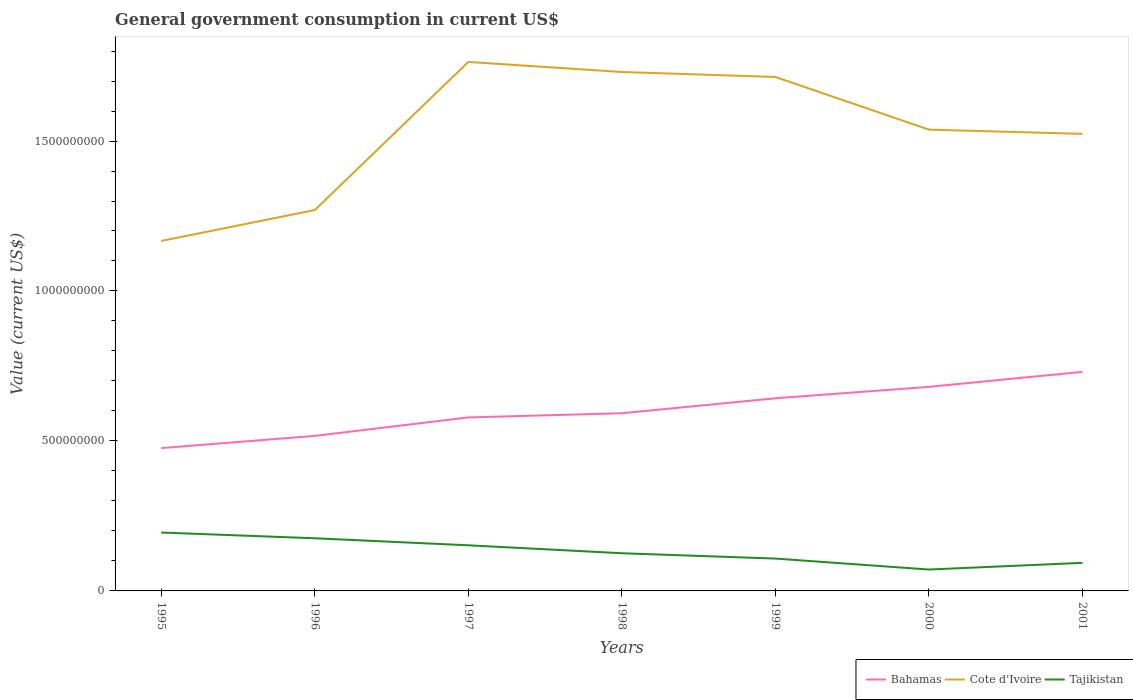Does the line corresponding to Bahamas intersect with the line corresponding to Cote d'Ivoire?
Your response must be concise. No. Across all years, what is the maximum government conusmption in Tajikistan?
Make the answer very short. 7.13e+07. In which year was the government conusmption in Cote d'Ivoire maximum?
Your answer should be very brief. 1995. What is the total government conusmption in Tajikistan in the graph?
Provide a short and direct response. 6.77e+07. What is the difference between the highest and the second highest government conusmption in Tajikistan?
Make the answer very short. 1.23e+08. What is the difference between the highest and the lowest government conusmption in Cote d'Ivoire?
Your answer should be compact. 4. Does the graph contain grids?
Your answer should be compact. No. Where does the legend appear in the graph?
Your response must be concise. Bottom right. How many legend labels are there?
Give a very brief answer. 3. What is the title of the graph?
Keep it short and to the point. General government consumption in current US$. What is the label or title of the Y-axis?
Your response must be concise. Value (current US$). What is the Value (current US$) in Bahamas in 1995?
Your response must be concise. 4.76e+08. What is the Value (current US$) in Cote d'Ivoire in 1995?
Your answer should be compact. 1.17e+09. What is the Value (current US$) of Tajikistan in 1995?
Provide a succinct answer. 1.95e+08. What is the Value (current US$) of Bahamas in 1996?
Make the answer very short. 5.17e+08. What is the Value (current US$) in Cote d'Ivoire in 1996?
Offer a terse response. 1.27e+09. What is the Value (current US$) in Tajikistan in 1996?
Provide a succinct answer. 1.76e+08. What is the Value (current US$) in Bahamas in 1997?
Make the answer very short. 5.78e+08. What is the Value (current US$) in Cote d'Ivoire in 1997?
Your response must be concise. 1.76e+09. What is the Value (current US$) of Tajikistan in 1997?
Offer a terse response. 1.52e+08. What is the Value (current US$) in Bahamas in 1998?
Ensure brevity in your answer.  5.92e+08. What is the Value (current US$) in Cote d'Ivoire in 1998?
Your answer should be very brief. 1.73e+09. What is the Value (current US$) in Tajikistan in 1998?
Give a very brief answer. 1.26e+08. What is the Value (current US$) in Bahamas in 1999?
Your answer should be very brief. 6.42e+08. What is the Value (current US$) in Cote d'Ivoire in 1999?
Keep it short and to the point. 1.71e+09. What is the Value (current US$) in Tajikistan in 1999?
Provide a short and direct response. 1.08e+08. What is the Value (current US$) in Bahamas in 2000?
Your answer should be compact. 6.80e+08. What is the Value (current US$) in Cote d'Ivoire in 2000?
Provide a succinct answer. 1.54e+09. What is the Value (current US$) of Tajikistan in 2000?
Offer a very short reply. 7.13e+07. What is the Value (current US$) in Bahamas in 2001?
Your answer should be very brief. 7.30e+08. What is the Value (current US$) of Cote d'Ivoire in 2001?
Ensure brevity in your answer.  1.52e+09. What is the Value (current US$) of Tajikistan in 2001?
Your response must be concise. 9.36e+07. Across all years, what is the maximum Value (current US$) in Bahamas?
Your answer should be very brief. 7.30e+08. Across all years, what is the maximum Value (current US$) in Cote d'Ivoire?
Your response must be concise. 1.76e+09. Across all years, what is the maximum Value (current US$) of Tajikistan?
Provide a short and direct response. 1.95e+08. Across all years, what is the minimum Value (current US$) in Bahamas?
Make the answer very short. 4.76e+08. Across all years, what is the minimum Value (current US$) in Cote d'Ivoire?
Make the answer very short. 1.17e+09. Across all years, what is the minimum Value (current US$) in Tajikistan?
Your answer should be very brief. 7.13e+07. What is the total Value (current US$) of Bahamas in the graph?
Keep it short and to the point. 4.22e+09. What is the total Value (current US$) in Cote d'Ivoire in the graph?
Ensure brevity in your answer.  1.07e+1. What is the total Value (current US$) in Tajikistan in the graph?
Your answer should be compact. 9.21e+08. What is the difference between the Value (current US$) in Bahamas in 1995 and that in 1996?
Your answer should be compact. -4.07e+07. What is the difference between the Value (current US$) in Cote d'Ivoire in 1995 and that in 1996?
Provide a short and direct response. -1.03e+08. What is the difference between the Value (current US$) of Tajikistan in 1995 and that in 1996?
Provide a short and direct response. 1.91e+07. What is the difference between the Value (current US$) of Bahamas in 1995 and that in 1997?
Provide a succinct answer. -1.02e+08. What is the difference between the Value (current US$) in Cote d'Ivoire in 1995 and that in 1997?
Keep it short and to the point. -5.97e+08. What is the difference between the Value (current US$) in Tajikistan in 1995 and that in 1997?
Ensure brevity in your answer.  4.26e+07. What is the difference between the Value (current US$) of Bahamas in 1995 and that in 1998?
Your response must be concise. -1.16e+08. What is the difference between the Value (current US$) of Cote d'Ivoire in 1995 and that in 1998?
Provide a short and direct response. -5.63e+08. What is the difference between the Value (current US$) of Tajikistan in 1995 and that in 1998?
Your answer should be very brief. 6.90e+07. What is the difference between the Value (current US$) in Bahamas in 1995 and that in 1999?
Provide a succinct answer. -1.66e+08. What is the difference between the Value (current US$) of Cote d'Ivoire in 1995 and that in 1999?
Ensure brevity in your answer.  -5.47e+08. What is the difference between the Value (current US$) of Tajikistan in 1995 and that in 1999?
Offer a terse response. 8.68e+07. What is the difference between the Value (current US$) in Bahamas in 1995 and that in 2000?
Your answer should be compact. -2.04e+08. What is the difference between the Value (current US$) of Cote d'Ivoire in 1995 and that in 2000?
Give a very brief answer. -3.71e+08. What is the difference between the Value (current US$) of Tajikistan in 1995 and that in 2000?
Make the answer very short. 1.23e+08. What is the difference between the Value (current US$) in Bahamas in 1995 and that in 2001?
Ensure brevity in your answer.  -2.54e+08. What is the difference between the Value (current US$) in Cote d'Ivoire in 1995 and that in 2001?
Make the answer very short. -3.57e+08. What is the difference between the Value (current US$) of Tajikistan in 1995 and that in 2001?
Provide a short and direct response. 1.01e+08. What is the difference between the Value (current US$) of Bahamas in 1996 and that in 1997?
Your answer should be compact. -6.16e+07. What is the difference between the Value (current US$) of Cote d'Ivoire in 1996 and that in 1997?
Your answer should be very brief. -4.94e+08. What is the difference between the Value (current US$) of Tajikistan in 1996 and that in 1997?
Provide a short and direct response. 2.35e+07. What is the difference between the Value (current US$) of Bahamas in 1996 and that in 1998?
Your response must be concise. -7.55e+07. What is the difference between the Value (current US$) in Cote d'Ivoire in 1996 and that in 1998?
Your answer should be very brief. -4.60e+08. What is the difference between the Value (current US$) of Tajikistan in 1996 and that in 1998?
Provide a succinct answer. 4.99e+07. What is the difference between the Value (current US$) of Bahamas in 1996 and that in 1999?
Ensure brevity in your answer.  -1.25e+08. What is the difference between the Value (current US$) of Cote d'Ivoire in 1996 and that in 1999?
Your answer should be very brief. -4.44e+08. What is the difference between the Value (current US$) in Tajikistan in 1996 and that in 1999?
Your answer should be compact. 6.77e+07. What is the difference between the Value (current US$) in Bahamas in 1996 and that in 2000?
Give a very brief answer. -1.64e+08. What is the difference between the Value (current US$) of Cote d'Ivoire in 1996 and that in 2000?
Ensure brevity in your answer.  -2.68e+08. What is the difference between the Value (current US$) in Tajikistan in 1996 and that in 2000?
Provide a succinct answer. 1.04e+08. What is the difference between the Value (current US$) of Bahamas in 1996 and that in 2001?
Provide a succinct answer. -2.14e+08. What is the difference between the Value (current US$) in Cote d'Ivoire in 1996 and that in 2001?
Provide a short and direct response. -2.54e+08. What is the difference between the Value (current US$) in Tajikistan in 1996 and that in 2001?
Provide a short and direct response. 8.20e+07. What is the difference between the Value (current US$) in Bahamas in 1997 and that in 1998?
Offer a terse response. -1.39e+07. What is the difference between the Value (current US$) of Cote d'Ivoire in 1997 and that in 1998?
Make the answer very short. 3.34e+07. What is the difference between the Value (current US$) in Tajikistan in 1997 and that in 1998?
Your response must be concise. 2.64e+07. What is the difference between the Value (current US$) in Bahamas in 1997 and that in 1999?
Make the answer very short. -6.38e+07. What is the difference between the Value (current US$) of Cote d'Ivoire in 1997 and that in 1999?
Offer a terse response. 5.01e+07. What is the difference between the Value (current US$) of Tajikistan in 1997 and that in 1999?
Provide a succinct answer. 4.43e+07. What is the difference between the Value (current US$) of Bahamas in 1997 and that in 2000?
Your response must be concise. -1.02e+08. What is the difference between the Value (current US$) of Cote d'Ivoire in 1997 and that in 2000?
Your response must be concise. 2.26e+08. What is the difference between the Value (current US$) in Tajikistan in 1997 and that in 2000?
Ensure brevity in your answer.  8.08e+07. What is the difference between the Value (current US$) of Bahamas in 1997 and that in 2001?
Ensure brevity in your answer.  -1.52e+08. What is the difference between the Value (current US$) in Cote d'Ivoire in 1997 and that in 2001?
Keep it short and to the point. 2.40e+08. What is the difference between the Value (current US$) in Tajikistan in 1997 and that in 2001?
Offer a very short reply. 5.85e+07. What is the difference between the Value (current US$) in Bahamas in 1998 and that in 1999?
Your answer should be very brief. -4.99e+07. What is the difference between the Value (current US$) in Cote d'Ivoire in 1998 and that in 1999?
Make the answer very short. 1.67e+07. What is the difference between the Value (current US$) in Tajikistan in 1998 and that in 1999?
Your answer should be very brief. 1.78e+07. What is the difference between the Value (current US$) in Bahamas in 1998 and that in 2000?
Offer a terse response. -8.80e+07. What is the difference between the Value (current US$) in Cote d'Ivoire in 1998 and that in 2000?
Ensure brevity in your answer.  1.92e+08. What is the difference between the Value (current US$) in Tajikistan in 1998 and that in 2000?
Your answer should be very brief. 5.43e+07. What is the difference between the Value (current US$) in Bahamas in 1998 and that in 2001?
Your response must be concise. -1.38e+08. What is the difference between the Value (current US$) of Cote d'Ivoire in 1998 and that in 2001?
Provide a short and direct response. 2.06e+08. What is the difference between the Value (current US$) in Tajikistan in 1998 and that in 2001?
Your answer should be very brief. 3.21e+07. What is the difference between the Value (current US$) in Bahamas in 1999 and that in 2000?
Ensure brevity in your answer.  -3.81e+07. What is the difference between the Value (current US$) of Cote d'Ivoire in 1999 and that in 2000?
Give a very brief answer. 1.75e+08. What is the difference between the Value (current US$) in Tajikistan in 1999 and that in 2000?
Your answer should be compact. 3.65e+07. What is the difference between the Value (current US$) in Bahamas in 1999 and that in 2001?
Ensure brevity in your answer.  -8.81e+07. What is the difference between the Value (current US$) of Cote d'Ivoire in 1999 and that in 2001?
Provide a succinct answer. 1.90e+08. What is the difference between the Value (current US$) in Tajikistan in 1999 and that in 2001?
Your answer should be very brief. 1.43e+07. What is the difference between the Value (current US$) of Bahamas in 2000 and that in 2001?
Provide a short and direct response. -5.00e+07. What is the difference between the Value (current US$) of Cote d'Ivoire in 2000 and that in 2001?
Offer a very short reply. 1.41e+07. What is the difference between the Value (current US$) of Tajikistan in 2000 and that in 2001?
Provide a succinct answer. -2.22e+07. What is the difference between the Value (current US$) in Bahamas in 1995 and the Value (current US$) in Cote d'Ivoire in 1996?
Your answer should be compact. -7.94e+08. What is the difference between the Value (current US$) in Bahamas in 1995 and the Value (current US$) in Tajikistan in 1996?
Offer a terse response. 3.01e+08. What is the difference between the Value (current US$) of Cote d'Ivoire in 1995 and the Value (current US$) of Tajikistan in 1996?
Make the answer very short. 9.91e+08. What is the difference between the Value (current US$) in Bahamas in 1995 and the Value (current US$) in Cote d'Ivoire in 1997?
Your answer should be very brief. -1.29e+09. What is the difference between the Value (current US$) in Bahamas in 1995 and the Value (current US$) in Tajikistan in 1997?
Provide a succinct answer. 3.24e+08. What is the difference between the Value (current US$) of Cote d'Ivoire in 1995 and the Value (current US$) of Tajikistan in 1997?
Offer a terse response. 1.01e+09. What is the difference between the Value (current US$) of Bahamas in 1995 and the Value (current US$) of Cote d'Ivoire in 1998?
Offer a very short reply. -1.25e+09. What is the difference between the Value (current US$) in Bahamas in 1995 and the Value (current US$) in Tajikistan in 1998?
Offer a very short reply. 3.51e+08. What is the difference between the Value (current US$) in Cote d'Ivoire in 1995 and the Value (current US$) in Tajikistan in 1998?
Make the answer very short. 1.04e+09. What is the difference between the Value (current US$) of Bahamas in 1995 and the Value (current US$) of Cote d'Ivoire in 1999?
Offer a terse response. -1.24e+09. What is the difference between the Value (current US$) in Bahamas in 1995 and the Value (current US$) in Tajikistan in 1999?
Offer a very short reply. 3.68e+08. What is the difference between the Value (current US$) of Cote d'Ivoire in 1995 and the Value (current US$) of Tajikistan in 1999?
Give a very brief answer. 1.06e+09. What is the difference between the Value (current US$) of Bahamas in 1995 and the Value (current US$) of Cote d'Ivoire in 2000?
Keep it short and to the point. -1.06e+09. What is the difference between the Value (current US$) in Bahamas in 1995 and the Value (current US$) in Tajikistan in 2000?
Provide a succinct answer. 4.05e+08. What is the difference between the Value (current US$) in Cote d'Ivoire in 1995 and the Value (current US$) in Tajikistan in 2000?
Provide a succinct answer. 1.10e+09. What is the difference between the Value (current US$) of Bahamas in 1995 and the Value (current US$) of Cote d'Ivoire in 2001?
Ensure brevity in your answer.  -1.05e+09. What is the difference between the Value (current US$) of Bahamas in 1995 and the Value (current US$) of Tajikistan in 2001?
Offer a very short reply. 3.83e+08. What is the difference between the Value (current US$) of Cote d'Ivoire in 1995 and the Value (current US$) of Tajikistan in 2001?
Your answer should be compact. 1.07e+09. What is the difference between the Value (current US$) of Bahamas in 1996 and the Value (current US$) of Cote d'Ivoire in 1997?
Your answer should be very brief. -1.25e+09. What is the difference between the Value (current US$) in Bahamas in 1996 and the Value (current US$) in Tajikistan in 1997?
Provide a short and direct response. 3.65e+08. What is the difference between the Value (current US$) in Cote d'Ivoire in 1996 and the Value (current US$) in Tajikistan in 1997?
Provide a succinct answer. 1.12e+09. What is the difference between the Value (current US$) in Bahamas in 1996 and the Value (current US$) in Cote d'Ivoire in 1998?
Your response must be concise. -1.21e+09. What is the difference between the Value (current US$) in Bahamas in 1996 and the Value (current US$) in Tajikistan in 1998?
Your answer should be very brief. 3.91e+08. What is the difference between the Value (current US$) of Cote d'Ivoire in 1996 and the Value (current US$) of Tajikistan in 1998?
Offer a terse response. 1.14e+09. What is the difference between the Value (current US$) of Bahamas in 1996 and the Value (current US$) of Cote d'Ivoire in 1999?
Give a very brief answer. -1.20e+09. What is the difference between the Value (current US$) of Bahamas in 1996 and the Value (current US$) of Tajikistan in 1999?
Give a very brief answer. 4.09e+08. What is the difference between the Value (current US$) in Cote d'Ivoire in 1996 and the Value (current US$) in Tajikistan in 1999?
Offer a terse response. 1.16e+09. What is the difference between the Value (current US$) of Bahamas in 1996 and the Value (current US$) of Cote d'Ivoire in 2000?
Offer a very short reply. -1.02e+09. What is the difference between the Value (current US$) of Bahamas in 1996 and the Value (current US$) of Tajikistan in 2000?
Your answer should be compact. 4.46e+08. What is the difference between the Value (current US$) in Cote d'Ivoire in 1996 and the Value (current US$) in Tajikistan in 2000?
Give a very brief answer. 1.20e+09. What is the difference between the Value (current US$) in Bahamas in 1996 and the Value (current US$) in Cote d'Ivoire in 2001?
Give a very brief answer. -1.01e+09. What is the difference between the Value (current US$) of Bahamas in 1996 and the Value (current US$) of Tajikistan in 2001?
Your answer should be compact. 4.23e+08. What is the difference between the Value (current US$) of Cote d'Ivoire in 1996 and the Value (current US$) of Tajikistan in 2001?
Offer a terse response. 1.18e+09. What is the difference between the Value (current US$) of Bahamas in 1997 and the Value (current US$) of Cote d'Ivoire in 1998?
Provide a succinct answer. -1.15e+09. What is the difference between the Value (current US$) in Bahamas in 1997 and the Value (current US$) in Tajikistan in 1998?
Ensure brevity in your answer.  4.53e+08. What is the difference between the Value (current US$) of Cote d'Ivoire in 1997 and the Value (current US$) of Tajikistan in 1998?
Provide a short and direct response. 1.64e+09. What is the difference between the Value (current US$) in Bahamas in 1997 and the Value (current US$) in Cote d'Ivoire in 1999?
Offer a terse response. -1.13e+09. What is the difference between the Value (current US$) of Bahamas in 1997 and the Value (current US$) of Tajikistan in 1999?
Provide a succinct answer. 4.71e+08. What is the difference between the Value (current US$) in Cote d'Ivoire in 1997 and the Value (current US$) in Tajikistan in 1999?
Provide a short and direct response. 1.66e+09. What is the difference between the Value (current US$) in Bahamas in 1997 and the Value (current US$) in Cote d'Ivoire in 2000?
Offer a terse response. -9.60e+08. What is the difference between the Value (current US$) in Bahamas in 1997 and the Value (current US$) in Tajikistan in 2000?
Offer a very short reply. 5.07e+08. What is the difference between the Value (current US$) of Cote d'Ivoire in 1997 and the Value (current US$) of Tajikistan in 2000?
Make the answer very short. 1.69e+09. What is the difference between the Value (current US$) in Bahamas in 1997 and the Value (current US$) in Cote d'Ivoire in 2001?
Your answer should be compact. -9.45e+08. What is the difference between the Value (current US$) in Bahamas in 1997 and the Value (current US$) in Tajikistan in 2001?
Ensure brevity in your answer.  4.85e+08. What is the difference between the Value (current US$) of Cote d'Ivoire in 1997 and the Value (current US$) of Tajikistan in 2001?
Offer a terse response. 1.67e+09. What is the difference between the Value (current US$) in Bahamas in 1998 and the Value (current US$) in Cote d'Ivoire in 1999?
Your answer should be very brief. -1.12e+09. What is the difference between the Value (current US$) in Bahamas in 1998 and the Value (current US$) in Tajikistan in 1999?
Keep it short and to the point. 4.85e+08. What is the difference between the Value (current US$) in Cote d'Ivoire in 1998 and the Value (current US$) in Tajikistan in 1999?
Your response must be concise. 1.62e+09. What is the difference between the Value (current US$) of Bahamas in 1998 and the Value (current US$) of Cote d'Ivoire in 2000?
Give a very brief answer. -9.46e+08. What is the difference between the Value (current US$) of Bahamas in 1998 and the Value (current US$) of Tajikistan in 2000?
Provide a succinct answer. 5.21e+08. What is the difference between the Value (current US$) in Cote d'Ivoire in 1998 and the Value (current US$) in Tajikistan in 2000?
Keep it short and to the point. 1.66e+09. What is the difference between the Value (current US$) in Bahamas in 1998 and the Value (current US$) in Cote d'Ivoire in 2001?
Your answer should be compact. -9.31e+08. What is the difference between the Value (current US$) in Bahamas in 1998 and the Value (current US$) in Tajikistan in 2001?
Offer a very short reply. 4.99e+08. What is the difference between the Value (current US$) in Cote d'Ivoire in 1998 and the Value (current US$) in Tajikistan in 2001?
Give a very brief answer. 1.64e+09. What is the difference between the Value (current US$) in Bahamas in 1999 and the Value (current US$) in Cote d'Ivoire in 2000?
Your answer should be compact. -8.96e+08. What is the difference between the Value (current US$) of Bahamas in 1999 and the Value (current US$) of Tajikistan in 2000?
Provide a short and direct response. 5.71e+08. What is the difference between the Value (current US$) of Cote d'Ivoire in 1999 and the Value (current US$) of Tajikistan in 2000?
Your answer should be very brief. 1.64e+09. What is the difference between the Value (current US$) of Bahamas in 1999 and the Value (current US$) of Cote d'Ivoire in 2001?
Offer a terse response. -8.82e+08. What is the difference between the Value (current US$) in Bahamas in 1999 and the Value (current US$) in Tajikistan in 2001?
Offer a terse response. 5.49e+08. What is the difference between the Value (current US$) in Cote d'Ivoire in 1999 and the Value (current US$) in Tajikistan in 2001?
Ensure brevity in your answer.  1.62e+09. What is the difference between the Value (current US$) of Bahamas in 2000 and the Value (current US$) of Cote d'Ivoire in 2001?
Your answer should be compact. -8.43e+08. What is the difference between the Value (current US$) in Bahamas in 2000 and the Value (current US$) in Tajikistan in 2001?
Offer a very short reply. 5.87e+08. What is the difference between the Value (current US$) of Cote d'Ivoire in 2000 and the Value (current US$) of Tajikistan in 2001?
Make the answer very short. 1.44e+09. What is the average Value (current US$) of Bahamas per year?
Give a very brief answer. 6.02e+08. What is the average Value (current US$) of Cote d'Ivoire per year?
Give a very brief answer. 1.53e+09. What is the average Value (current US$) of Tajikistan per year?
Your answer should be compact. 1.32e+08. In the year 1995, what is the difference between the Value (current US$) of Bahamas and Value (current US$) of Cote d'Ivoire?
Offer a very short reply. -6.91e+08. In the year 1995, what is the difference between the Value (current US$) of Bahamas and Value (current US$) of Tajikistan?
Give a very brief answer. 2.82e+08. In the year 1995, what is the difference between the Value (current US$) of Cote d'Ivoire and Value (current US$) of Tajikistan?
Make the answer very short. 9.72e+08. In the year 1996, what is the difference between the Value (current US$) of Bahamas and Value (current US$) of Cote d'Ivoire?
Offer a very short reply. -7.53e+08. In the year 1996, what is the difference between the Value (current US$) in Bahamas and Value (current US$) in Tajikistan?
Offer a terse response. 3.41e+08. In the year 1996, what is the difference between the Value (current US$) of Cote d'Ivoire and Value (current US$) of Tajikistan?
Keep it short and to the point. 1.09e+09. In the year 1997, what is the difference between the Value (current US$) of Bahamas and Value (current US$) of Cote d'Ivoire?
Your answer should be compact. -1.19e+09. In the year 1997, what is the difference between the Value (current US$) of Bahamas and Value (current US$) of Tajikistan?
Provide a succinct answer. 4.26e+08. In the year 1997, what is the difference between the Value (current US$) of Cote d'Ivoire and Value (current US$) of Tajikistan?
Offer a terse response. 1.61e+09. In the year 1998, what is the difference between the Value (current US$) of Bahamas and Value (current US$) of Cote d'Ivoire?
Your answer should be compact. -1.14e+09. In the year 1998, what is the difference between the Value (current US$) of Bahamas and Value (current US$) of Tajikistan?
Your answer should be very brief. 4.67e+08. In the year 1998, what is the difference between the Value (current US$) in Cote d'Ivoire and Value (current US$) in Tajikistan?
Provide a short and direct response. 1.60e+09. In the year 1999, what is the difference between the Value (current US$) of Bahamas and Value (current US$) of Cote d'Ivoire?
Your answer should be compact. -1.07e+09. In the year 1999, what is the difference between the Value (current US$) in Bahamas and Value (current US$) in Tajikistan?
Offer a very short reply. 5.34e+08. In the year 1999, what is the difference between the Value (current US$) in Cote d'Ivoire and Value (current US$) in Tajikistan?
Provide a succinct answer. 1.61e+09. In the year 2000, what is the difference between the Value (current US$) of Bahamas and Value (current US$) of Cote d'Ivoire?
Make the answer very short. -8.58e+08. In the year 2000, what is the difference between the Value (current US$) of Bahamas and Value (current US$) of Tajikistan?
Your response must be concise. 6.09e+08. In the year 2000, what is the difference between the Value (current US$) in Cote d'Ivoire and Value (current US$) in Tajikistan?
Your answer should be compact. 1.47e+09. In the year 2001, what is the difference between the Value (current US$) in Bahamas and Value (current US$) in Cote d'Ivoire?
Keep it short and to the point. -7.93e+08. In the year 2001, what is the difference between the Value (current US$) of Bahamas and Value (current US$) of Tajikistan?
Offer a very short reply. 6.37e+08. In the year 2001, what is the difference between the Value (current US$) of Cote d'Ivoire and Value (current US$) of Tajikistan?
Offer a terse response. 1.43e+09. What is the ratio of the Value (current US$) in Bahamas in 1995 to that in 1996?
Your response must be concise. 0.92. What is the ratio of the Value (current US$) of Cote d'Ivoire in 1995 to that in 1996?
Your answer should be compact. 0.92. What is the ratio of the Value (current US$) in Tajikistan in 1995 to that in 1996?
Offer a very short reply. 1.11. What is the ratio of the Value (current US$) of Bahamas in 1995 to that in 1997?
Your answer should be compact. 0.82. What is the ratio of the Value (current US$) in Cote d'Ivoire in 1995 to that in 1997?
Make the answer very short. 0.66. What is the ratio of the Value (current US$) of Tajikistan in 1995 to that in 1997?
Offer a very short reply. 1.28. What is the ratio of the Value (current US$) of Bahamas in 1995 to that in 1998?
Your answer should be very brief. 0.8. What is the ratio of the Value (current US$) of Cote d'Ivoire in 1995 to that in 1998?
Offer a very short reply. 0.67. What is the ratio of the Value (current US$) of Tajikistan in 1995 to that in 1998?
Offer a very short reply. 1.55. What is the ratio of the Value (current US$) in Bahamas in 1995 to that in 1999?
Offer a very short reply. 0.74. What is the ratio of the Value (current US$) of Cote d'Ivoire in 1995 to that in 1999?
Give a very brief answer. 0.68. What is the ratio of the Value (current US$) in Tajikistan in 1995 to that in 1999?
Your response must be concise. 1.8. What is the ratio of the Value (current US$) of Bahamas in 1995 to that in 2000?
Offer a very short reply. 0.7. What is the ratio of the Value (current US$) in Cote d'Ivoire in 1995 to that in 2000?
Make the answer very short. 0.76. What is the ratio of the Value (current US$) in Tajikistan in 1995 to that in 2000?
Provide a short and direct response. 2.73. What is the ratio of the Value (current US$) of Bahamas in 1995 to that in 2001?
Your answer should be very brief. 0.65. What is the ratio of the Value (current US$) of Cote d'Ivoire in 1995 to that in 2001?
Offer a very short reply. 0.77. What is the ratio of the Value (current US$) in Tajikistan in 1995 to that in 2001?
Your answer should be compact. 2.08. What is the ratio of the Value (current US$) in Bahamas in 1996 to that in 1997?
Keep it short and to the point. 0.89. What is the ratio of the Value (current US$) of Cote d'Ivoire in 1996 to that in 1997?
Your answer should be compact. 0.72. What is the ratio of the Value (current US$) in Tajikistan in 1996 to that in 1997?
Keep it short and to the point. 1.15. What is the ratio of the Value (current US$) in Bahamas in 1996 to that in 1998?
Make the answer very short. 0.87. What is the ratio of the Value (current US$) in Cote d'Ivoire in 1996 to that in 1998?
Ensure brevity in your answer.  0.73. What is the ratio of the Value (current US$) in Tajikistan in 1996 to that in 1998?
Your response must be concise. 1.4. What is the ratio of the Value (current US$) of Bahamas in 1996 to that in 1999?
Your answer should be very brief. 0.8. What is the ratio of the Value (current US$) in Cote d'Ivoire in 1996 to that in 1999?
Provide a succinct answer. 0.74. What is the ratio of the Value (current US$) of Tajikistan in 1996 to that in 1999?
Your answer should be very brief. 1.63. What is the ratio of the Value (current US$) of Bahamas in 1996 to that in 2000?
Your answer should be compact. 0.76. What is the ratio of the Value (current US$) of Cote d'Ivoire in 1996 to that in 2000?
Your answer should be compact. 0.83. What is the ratio of the Value (current US$) in Tajikistan in 1996 to that in 2000?
Your answer should be compact. 2.46. What is the ratio of the Value (current US$) of Bahamas in 1996 to that in 2001?
Keep it short and to the point. 0.71. What is the ratio of the Value (current US$) of Tajikistan in 1996 to that in 2001?
Ensure brevity in your answer.  1.88. What is the ratio of the Value (current US$) of Bahamas in 1997 to that in 1998?
Offer a very short reply. 0.98. What is the ratio of the Value (current US$) in Cote d'Ivoire in 1997 to that in 1998?
Your answer should be very brief. 1.02. What is the ratio of the Value (current US$) in Tajikistan in 1997 to that in 1998?
Offer a terse response. 1.21. What is the ratio of the Value (current US$) in Bahamas in 1997 to that in 1999?
Keep it short and to the point. 0.9. What is the ratio of the Value (current US$) of Cote d'Ivoire in 1997 to that in 1999?
Your answer should be very brief. 1.03. What is the ratio of the Value (current US$) in Tajikistan in 1997 to that in 1999?
Your answer should be compact. 1.41. What is the ratio of the Value (current US$) of Bahamas in 1997 to that in 2000?
Keep it short and to the point. 0.85. What is the ratio of the Value (current US$) of Cote d'Ivoire in 1997 to that in 2000?
Make the answer very short. 1.15. What is the ratio of the Value (current US$) in Tajikistan in 1997 to that in 2000?
Provide a short and direct response. 2.13. What is the ratio of the Value (current US$) in Bahamas in 1997 to that in 2001?
Provide a succinct answer. 0.79. What is the ratio of the Value (current US$) of Cote d'Ivoire in 1997 to that in 2001?
Keep it short and to the point. 1.16. What is the ratio of the Value (current US$) of Tajikistan in 1997 to that in 2001?
Your answer should be very brief. 1.63. What is the ratio of the Value (current US$) of Bahamas in 1998 to that in 1999?
Offer a terse response. 0.92. What is the ratio of the Value (current US$) of Cote d'Ivoire in 1998 to that in 1999?
Make the answer very short. 1.01. What is the ratio of the Value (current US$) in Tajikistan in 1998 to that in 1999?
Make the answer very short. 1.17. What is the ratio of the Value (current US$) in Bahamas in 1998 to that in 2000?
Your answer should be very brief. 0.87. What is the ratio of the Value (current US$) in Cote d'Ivoire in 1998 to that in 2000?
Ensure brevity in your answer.  1.12. What is the ratio of the Value (current US$) of Tajikistan in 1998 to that in 2000?
Your response must be concise. 1.76. What is the ratio of the Value (current US$) in Bahamas in 1998 to that in 2001?
Make the answer very short. 0.81. What is the ratio of the Value (current US$) of Cote d'Ivoire in 1998 to that in 2001?
Your response must be concise. 1.14. What is the ratio of the Value (current US$) of Tajikistan in 1998 to that in 2001?
Provide a succinct answer. 1.34. What is the ratio of the Value (current US$) in Bahamas in 1999 to that in 2000?
Make the answer very short. 0.94. What is the ratio of the Value (current US$) of Cote d'Ivoire in 1999 to that in 2000?
Your answer should be very brief. 1.11. What is the ratio of the Value (current US$) in Tajikistan in 1999 to that in 2000?
Keep it short and to the point. 1.51. What is the ratio of the Value (current US$) of Bahamas in 1999 to that in 2001?
Your response must be concise. 0.88. What is the ratio of the Value (current US$) in Cote d'Ivoire in 1999 to that in 2001?
Your response must be concise. 1.12. What is the ratio of the Value (current US$) of Tajikistan in 1999 to that in 2001?
Keep it short and to the point. 1.15. What is the ratio of the Value (current US$) in Bahamas in 2000 to that in 2001?
Give a very brief answer. 0.93. What is the ratio of the Value (current US$) of Cote d'Ivoire in 2000 to that in 2001?
Offer a terse response. 1.01. What is the ratio of the Value (current US$) in Tajikistan in 2000 to that in 2001?
Make the answer very short. 0.76. What is the difference between the highest and the second highest Value (current US$) of Bahamas?
Your response must be concise. 5.00e+07. What is the difference between the highest and the second highest Value (current US$) in Cote d'Ivoire?
Offer a terse response. 3.34e+07. What is the difference between the highest and the second highest Value (current US$) in Tajikistan?
Give a very brief answer. 1.91e+07. What is the difference between the highest and the lowest Value (current US$) in Bahamas?
Provide a short and direct response. 2.54e+08. What is the difference between the highest and the lowest Value (current US$) of Cote d'Ivoire?
Offer a terse response. 5.97e+08. What is the difference between the highest and the lowest Value (current US$) of Tajikistan?
Your answer should be compact. 1.23e+08. 